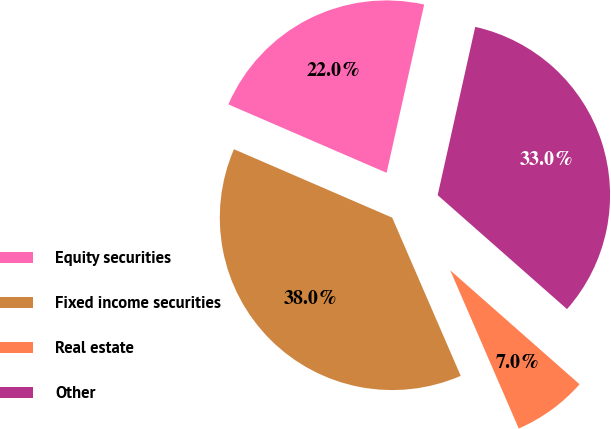Convert chart. <chart><loc_0><loc_0><loc_500><loc_500><pie_chart><fcel>Equity securities<fcel>Fixed income securities<fcel>Real estate<fcel>Other<nl><fcel>22.0%<fcel>38.0%<fcel>7.0%<fcel>33.0%<nl></chart> 